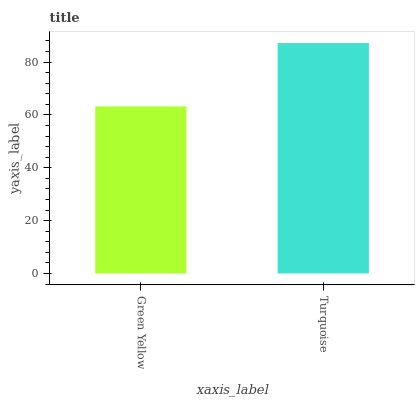Is Green Yellow the minimum?
Answer yes or no. Yes. Is Turquoise the maximum?
Answer yes or no. Yes. Is Turquoise the minimum?
Answer yes or no. No. Is Turquoise greater than Green Yellow?
Answer yes or no. Yes. Is Green Yellow less than Turquoise?
Answer yes or no. Yes. Is Green Yellow greater than Turquoise?
Answer yes or no. No. Is Turquoise less than Green Yellow?
Answer yes or no. No. Is Turquoise the high median?
Answer yes or no. Yes. Is Green Yellow the low median?
Answer yes or no. Yes. Is Green Yellow the high median?
Answer yes or no. No. Is Turquoise the low median?
Answer yes or no. No. 